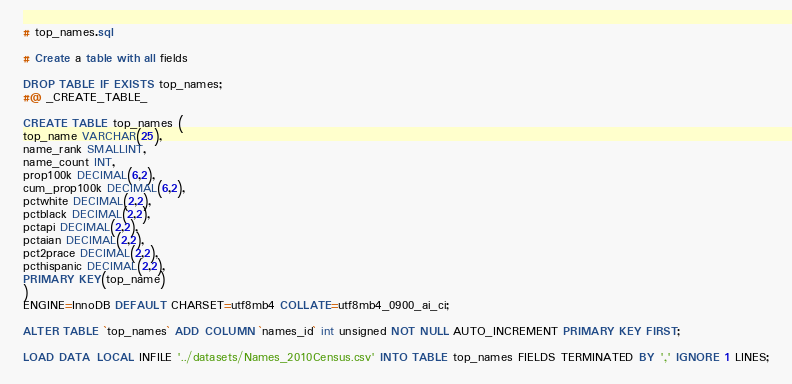<code> <loc_0><loc_0><loc_500><loc_500><_SQL_># top_names.sql

# Create a table with all fields

DROP TABLE IF EXISTS top_names;
#@ _CREATE_TABLE_

CREATE TABLE top_names (
top_name VARCHAR(25),
name_rank SMALLINT,
name_count INT,
prop100k DECIMAL(6,2),
cum_prop100k DECIMAL(6,2),
pctwhite DECIMAL(2,2),
pctblack DECIMAL(2,2),
pctapi DECIMAL(2,2),
pctaian DECIMAL(2,2),
pct2prace DECIMAL(2,2),
pcthispanic DECIMAL(2,2),
PRIMARY KEY(top_name)
)
ENGINE=InnoDB DEFAULT CHARSET=utf8mb4 COLLATE=utf8mb4_0900_ai_ci;

ALTER TABLE `top_names` ADD COLUMN `names_id` int unsigned NOT NULL AUTO_INCREMENT PRIMARY KEY FIRST;

LOAD DATA LOCAL INFILE '../datasets/Names_2010Census.csv' INTO TABLE top_names FIELDS TERMINATED BY ',' IGNORE 1 LINES;
</code> 